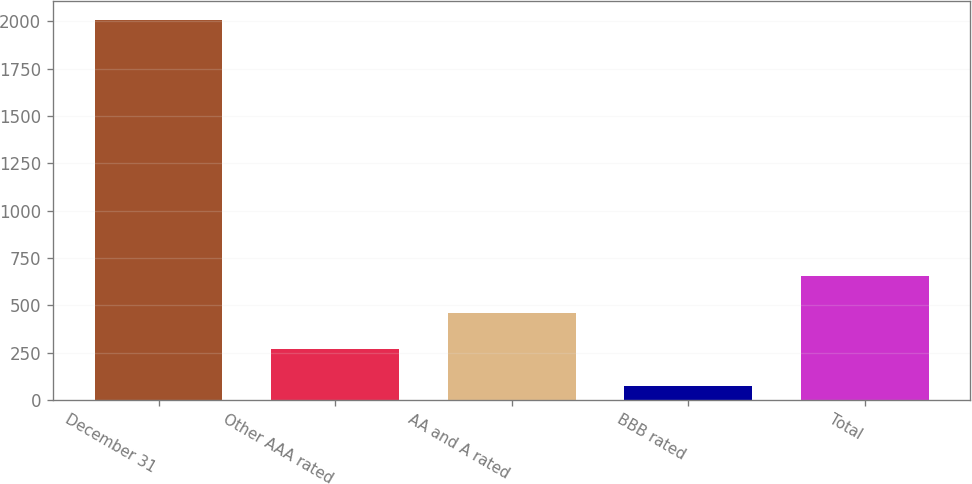Convert chart to OTSL. <chart><loc_0><loc_0><loc_500><loc_500><bar_chart><fcel>December 31<fcel>Other AAA rated<fcel>AA and A rated<fcel>BBB rated<fcel>Total<nl><fcel>2006<fcel>268.1<fcel>461.2<fcel>75<fcel>654.3<nl></chart> 